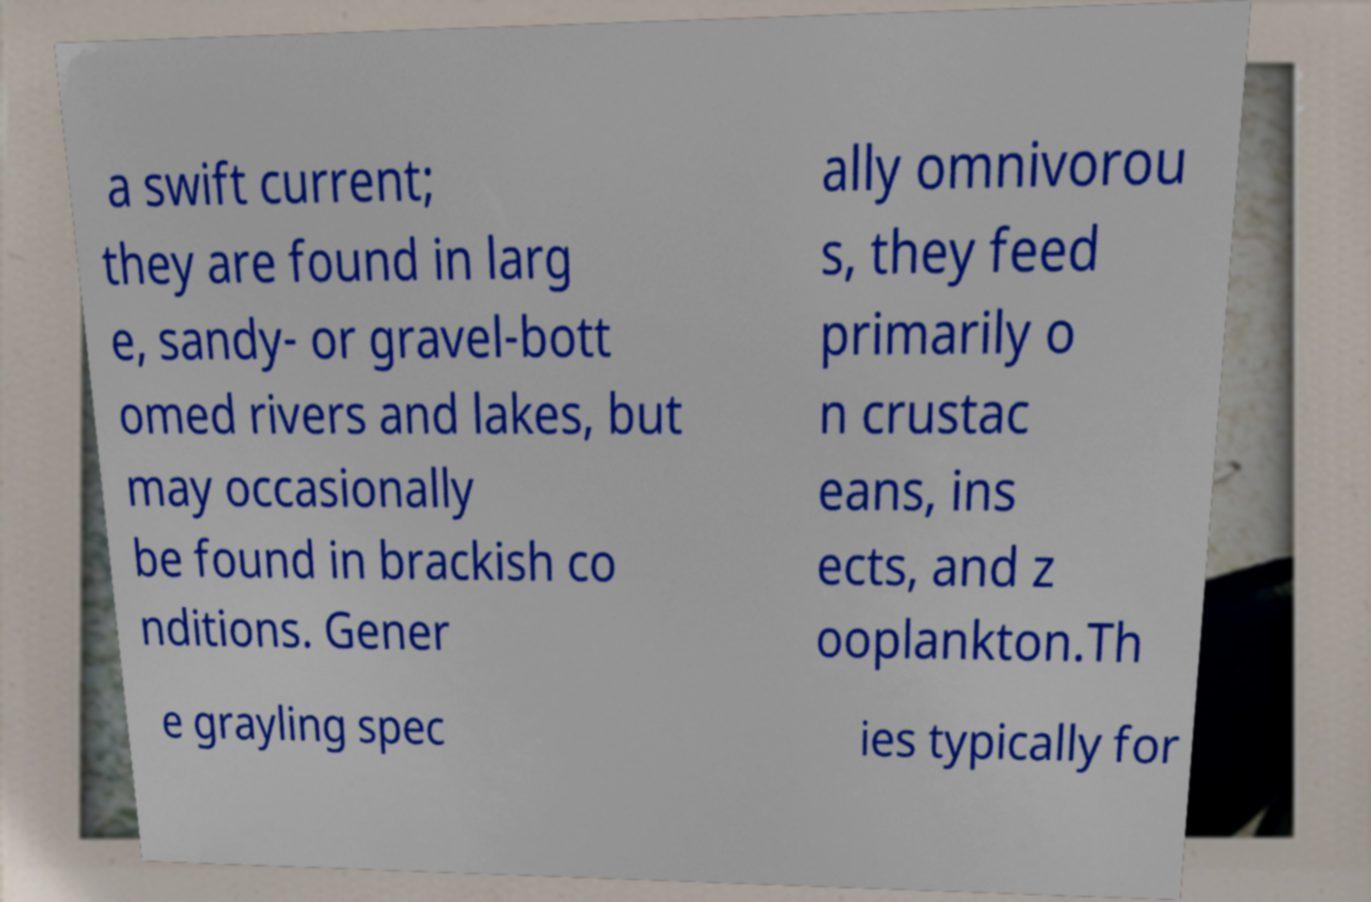Please read and relay the text visible in this image. What does it say? a swift current; they are found in larg e, sandy- or gravel-bott omed rivers and lakes, but may occasionally be found in brackish co nditions. Gener ally omnivorou s, they feed primarily o n crustac eans, ins ects, and z ooplankton.Th e grayling spec ies typically for 